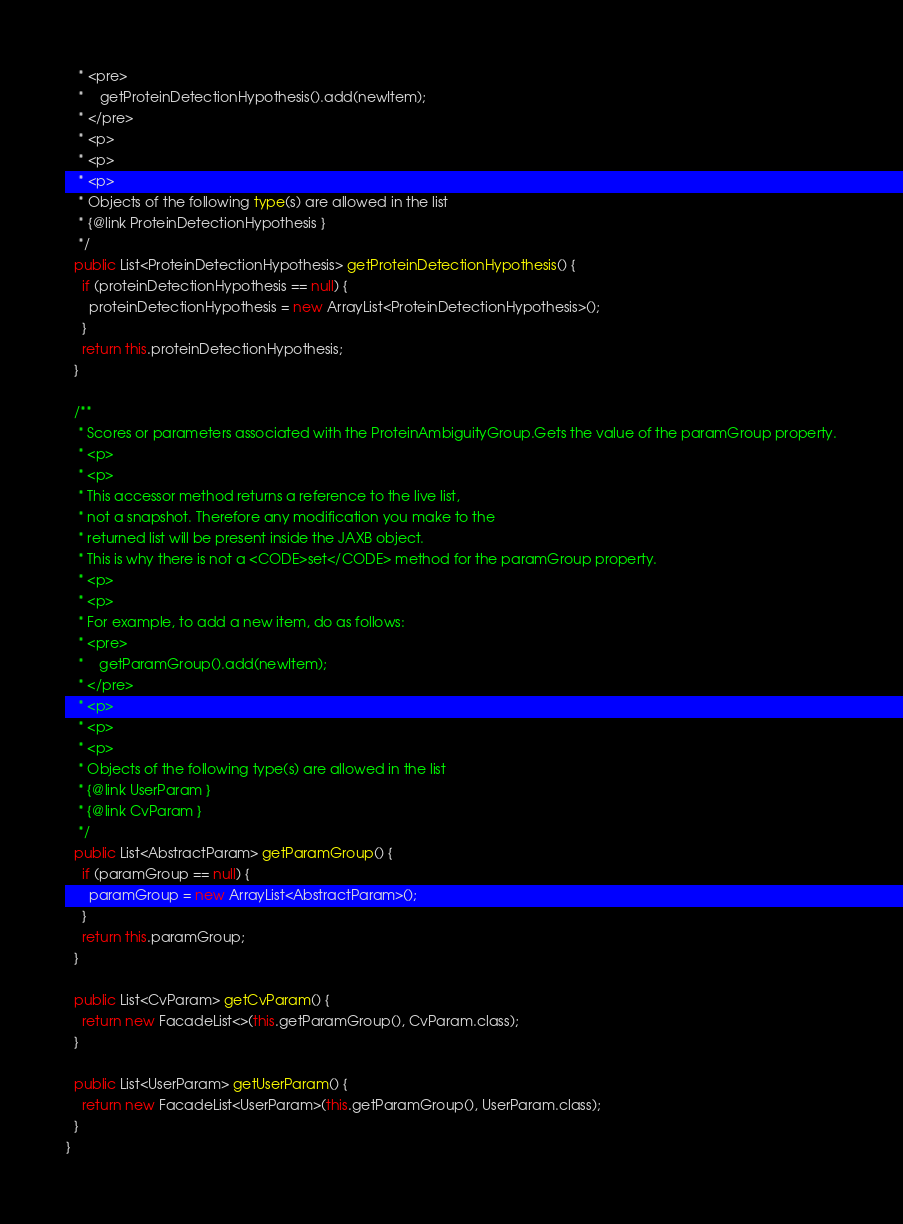Convert code to text. <code><loc_0><loc_0><loc_500><loc_500><_Java_>   * <pre>
   *    getProteinDetectionHypothesis().add(newItem);
   * </pre>
   * <p>
   * <p>
   * <p>
   * Objects of the following type(s) are allowed in the list
   * {@link ProteinDetectionHypothesis }
   */
  public List<ProteinDetectionHypothesis> getProteinDetectionHypothesis() {
    if (proteinDetectionHypothesis == null) {
      proteinDetectionHypothesis = new ArrayList<ProteinDetectionHypothesis>();
    }
    return this.proteinDetectionHypothesis;
  }

  /**
   * Scores or parameters associated with the ProteinAmbiguityGroup.Gets the value of the paramGroup property.
   * <p>
   * <p>
   * This accessor method returns a reference to the live list,
   * not a snapshot. Therefore any modification you make to the
   * returned list will be present inside the JAXB object.
   * This is why there is not a <CODE>set</CODE> method for the paramGroup property.
   * <p>
   * <p>
   * For example, to add a new item, do as follows:
   * <pre>
   *    getParamGroup().add(newItem);
   * </pre>
   * <p>
   * <p>
   * <p>
   * Objects of the following type(s) are allowed in the list
   * {@link UserParam }
   * {@link CvParam }
   */
  public List<AbstractParam> getParamGroup() {
    if (paramGroup == null) {
      paramGroup = new ArrayList<AbstractParam>();
    }
    return this.paramGroup;
  }

  public List<CvParam> getCvParam() {
    return new FacadeList<>(this.getParamGroup(), CvParam.class);
  }

  public List<UserParam> getUserParam() {
    return new FacadeList<UserParam>(this.getParamGroup(), UserParam.class);
  }
}
</code> 